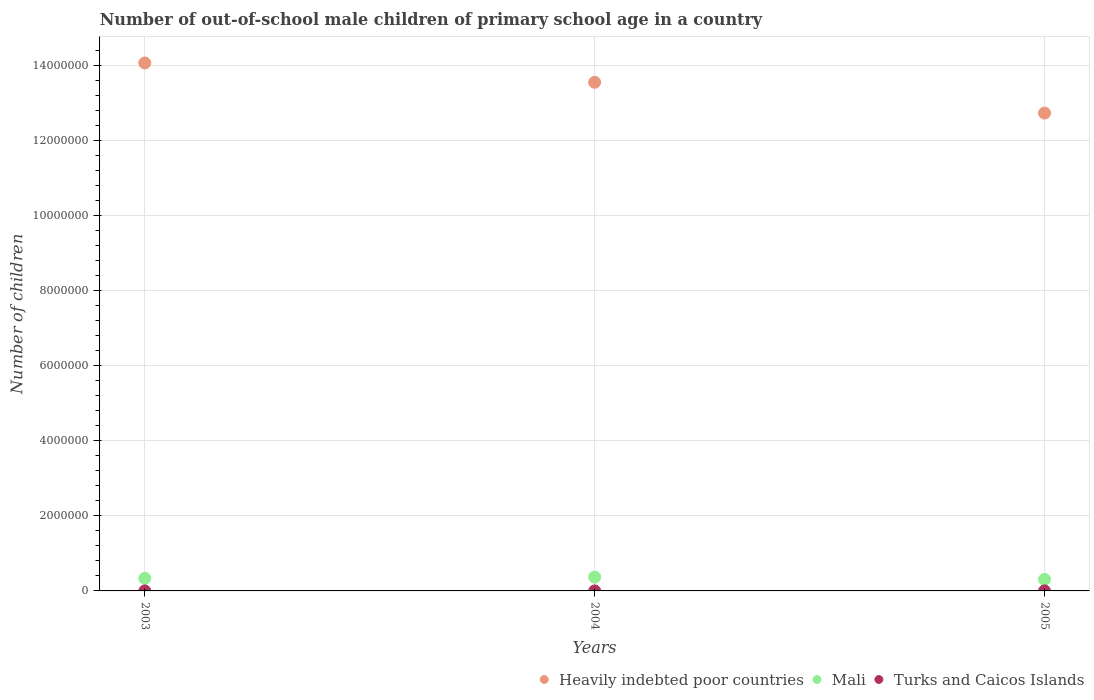Is the number of dotlines equal to the number of legend labels?
Offer a terse response. Yes. What is the number of out-of-school male children in Mali in 2003?
Offer a very short reply. 3.36e+05. Across all years, what is the maximum number of out-of-school male children in Mali?
Give a very brief answer. 3.68e+05. Across all years, what is the minimum number of out-of-school male children in Turks and Caicos Islands?
Offer a terse response. 219. In which year was the number of out-of-school male children in Heavily indebted poor countries minimum?
Ensure brevity in your answer.  2005. What is the total number of out-of-school male children in Heavily indebted poor countries in the graph?
Give a very brief answer. 4.04e+07. What is the difference between the number of out-of-school male children in Heavily indebted poor countries in 2003 and that in 2005?
Make the answer very short. 1.34e+06. What is the difference between the number of out-of-school male children in Heavily indebted poor countries in 2004 and the number of out-of-school male children in Mali in 2003?
Your response must be concise. 1.32e+07. What is the average number of out-of-school male children in Mali per year?
Offer a terse response. 3.37e+05. In the year 2005, what is the difference between the number of out-of-school male children in Turks and Caicos Islands and number of out-of-school male children in Heavily indebted poor countries?
Your answer should be compact. -1.27e+07. What is the ratio of the number of out-of-school male children in Mali in 2003 to that in 2004?
Provide a short and direct response. 0.91. Is the difference between the number of out-of-school male children in Turks and Caicos Islands in 2003 and 2005 greater than the difference between the number of out-of-school male children in Heavily indebted poor countries in 2003 and 2005?
Your response must be concise. No. What is the difference between the highest and the second highest number of out-of-school male children in Heavily indebted poor countries?
Keep it short and to the point. 5.15e+05. In how many years, is the number of out-of-school male children in Mali greater than the average number of out-of-school male children in Mali taken over all years?
Offer a terse response. 1. Is the sum of the number of out-of-school male children in Mali in 2003 and 2004 greater than the maximum number of out-of-school male children in Turks and Caicos Islands across all years?
Your answer should be compact. Yes. Does the number of out-of-school male children in Turks and Caicos Islands monotonically increase over the years?
Give a very brief answer. No. Is the number of out-of-school male children in Turks and Caicos Islands strictly greater than the number of out-of-school male children in Heavily indebted poor countries over the years?
Ensure brevity in your answer.  No. Is the number of out-of-school male children in Mali strictly less than the number of out-of-school male children in Heavily indebted poor countries over the years?
Give a very brief answer. Yes. How many years are there in the graph?
Provide a succinct answer. 3. What is the difference between two consecutive major ticks on the Y-axis?
Give a very brief answer. 2.00e+06. Does the graph contain any zero values?
Provide a short and direct response. No. Does the graph contain grids?
Provide a short and direct response. Yes. Where does the legend appear in the graph?
Ensure brevity in your answer.  Bottom right. How are the legend labels stacked?
Make the answer very short. Horizontal. What is the title of the graph?
Provide a succinct answer. Number of out-of-school male children of primary school age in a country. Does "American Samoa" appear as one of the legend labels in the graph?
Provide a short and direct response. No. What is the label or title of the X-axis?
Your answer should be compact. Years. What is the label or title of the Y-axis?
Your answer should be very brief. Number of children. What is the Number of children of Heavily indebted poor countries in 2003?
Your answer should be compact. 1.41e+07. What is the Number of children of Mali in 2003?
Keep it short and to the point. 3.36e+05. What is the Number of children in Turks and Caicos Islands in 2003?
Offer a very short reply. 264. What is the Number of children of Heavily indebted poor countries in 2004?
Make the answer very short. 1.36e+07. What is the Number of children of Mali in 2004?
Ensure brevity in your answer.  3.68e+05. What is the Number of children in Turks and Caicos Islands in 2004?
Ensure brevity in your answer.  219. What is the Number of children of Heavily indebted poor countries in 2005?
Your response must be concise. 1.27e+07. What is the Number of children in Mali in 2005?
Provide a short and direct response. 3.08e+05. What is the Number of children of Turks and Caicos Islands in 2005?
Provide a succinct answer. 278. Across all years, what is the maximum Number of children of Heavily indebted poor countries?
Ensure brevity in your answer.  1.41e+07. Across all years, what is the maximum Number of children in Mali?
Offer a terse response. 3.68e+05. Across all years, what is the maximum Number of children in Turks and Caicos Islands?
Provide a succinct answer. 278. Across all years, what is the minimum Number of children in Heavily indebted poor countries?
Offer a very short reply. 1.27e+07. Across all years, what is the minimum Number of children in Mali?
Make the answer very short. 3.08e+05. Across all years, what is the minimum Number of children of Turks and Caicos Islands?
Your answer should be very brief. 219. What is the total Number of children in Heavily indebted poor countries in the graph?
Offer a terse response. 4.04e+07. What is the total Number of children in Mali in the graph?
Offer a very short reply. 1.01e+06. What is the total Number of children of Turks and Caicos Islands in the graph?
Make the answer very short. 761. What is the difference between the Number of children of Heavily indebted poor countries in 2003 and that in 2004?
Keep it short and to the point. 5.15e+05. What is the difference between the Number of children of Mali in 2003 and that in 2004?
Your answer should be very brief. -3.29e+04. What is the difference between the Number of children in Turks and Caicos Islands in 2003 and that in 2004?
Offer a terse response. 45. What is the difference between the Number of children of Heavily indebted poor countries in 2003 and that in 2005?
Provide a succinct answer. 1.34e+06. What is the difference between the Number of children of Mali in 2003 and that in 2005?
Your answer should be very brief. 2.72e+04. What is the difference between the Number of children in Turks and Caicos Islands in 2003 and that in 2005?
Provide a succinct answer. -14. What is the difference between the Number of children of Heavily indebted poor countries in 2004 and that in 2005?
Keep it short and to the point. 8.20e+05. What is the difference between the Number of children of Mali in 2004 and that in 2005?
Keep it short and to the point. 6.00e+04. What is the difference between the Number of children in Turks and Caicos Islands in 2004 and that in 2005?
Ensure brevity in your answer.  -59. What is the difference between the Number of children in Heavily indebted poor countries in 2003 and the Number of children in Mali in 2004?
Your answer should be very brief. 1.37e+07. What is the difference between the Number of children in Heavily indebted poor countries in 2003 and the Number of children in Turks and Caicos Islands in 2004?
Your response must be concise. 1.41e+07. What is the difference between the Number of children of Mali in 2003 and the Number of children of Turks and Caicos Islands in 2004?
Provide a succinct answer. 3.35e+05. What is the difference between the Number of children of Heavily indebted poor countries in 2003 and the Number of children of Mali in 2005?
Provide a short and direct response. 1.38e+07. What is the difference between the Number of children of Heavily indebted poor countries in 2003 and the Number of children of Turks and Caicos Islands in 2005?
Give a very brief answer. 1.41e+07. What is the difference between the Number of children in Mali in 2003 and the Number of children in Turks and Caicos Islands in 2005?
Give a very brief answer. 3.35e+05. What is the difference between the Number of children in Heavily indebted poor countries in 2004 and the Number of children in Mali in 2005?
Ensure brevity in your answer.  1.33e+07. What is the difference between the Number of children of Heavily indebted poor countries in 2004 and the Number of children of Turks and Caicos Islands in 2005?
Your answer should be very brief. 1.36e+07. What is the difference between the Number of children in Mali in 2004 and the Number of children in Turks and Caicos Islands in 2005?
Provide a succinct answer. 3.68e+05. What is the average Number of children of Heavily indebted poor countries per year?
Give a very brief answer. 1.35e+07. What is the average Number of children in Mali per year?
Your answer should be compact. 3.37e+05. What is the average Number of children in Turks and Caicos Islands per year?
Your answer should be compact. 253.67. In the year 2003, what is the difference between the Number of children of Heavily indebted poor countries and Number of children of Mali?
Your response must be concise. 1.37e+07. In the year 2003, what is the difference between the Number of children of Heavily indebted poor countries and Number of children of Turks and Caicos Islands?
Offer a very short reply. 1.41e+07. In the year 2003, what is the difference between the Number of children of Mali and Number of children of Turks and Caicos Islands?
Offer a very short reply. 3.35e+05. In the year 2004, what is the difference between the Number of children in Heavily indebted poor countries and Number of children in Mali?
Offer a terse response. 1.32e+07. In the year 2004, what is the difference between the Number of children of Heavily indebted poor countries and Number of children of Turks and Caicos Islands?
Keep it short and to the point. 1.36e+07. In the year 2004, what is the difference between the Number of children in Mali and Number of children in Turks and Caicos Islands?
Provide a succinct answer. 3.68e+05. In the year 2005, what is the difference between the Number of children in Heavily indebted poor countries and Number of children in Mali?
Make the answer very short. 1.24e+07. In the year 2005, what is the difference between the Number of children of Heavily indebted poor countries and Number of children of Turks and Caicos Islands?
Make the answer very short. 1.27e+07. In the year 2005, what is the difference between the Number of children in Mali and Number of children in Turks and Caicos Islands?
Ensure brevity in your answer.  3.08e+05. What is the ratio of the Number of children in Heavily indebted poor countries in 2003 to that in 2004?
Keep it short and to the point. 1.04. What is the ratio of the Number of children in Mali in 2003 to that in 2004?
Make the answer very short. 0.91. What is the ratio of the Number of children of Turks and Caicos Islands in 2003 to that in 2004?
Provide a short and direct response. 1.21. What is the ratio of the Number of children in Heavily indebted poor countries in 2003 to that in 2005?
Provide a short and direct response. 1.1. What is the ratio of the Number of children of Mali in 2003 to that in 2005?
Your response must be concise. 1.09. What is the ratio of the Number of children of Turks and Caicos Islands in 2003 to that in 2005?
Your answer should be very brief. 0.95. What is the ratio of the Number of children of Heavily indebted poor countries in 2004 to that in 2005?
Ensure brevity in your answer.  1.06. What is the ratio of the Number of children of Mali in 2004 to that in 2005?
Ensure brevity in your answer.  1.19. What is the ratio of the Number of children in Turks and Caicos Islands in 2004 to that in 2005?
Your answer should be very brief. 0.79. What is the difference between the highest and the second highest Number of children of Heavily indebted poor countries?
Offer a terse response. 5.15e+05. What is the difference between the highest and the second highest Number of children in Mali?
Offer a terse response. 3.29e+04. What is the difference between the highest and the lowest Number of children in Heavily indebted poor countries?
Your answer should be compact. 1.34e+06. What is the difference between the highest and the lowest Number of children of Mali?
Offer a terse response. 6.00e+04. What is the difference between the highest and the lowest Number of children in Turks and Caicos Islands?
Provide a short and direct response. 59. 